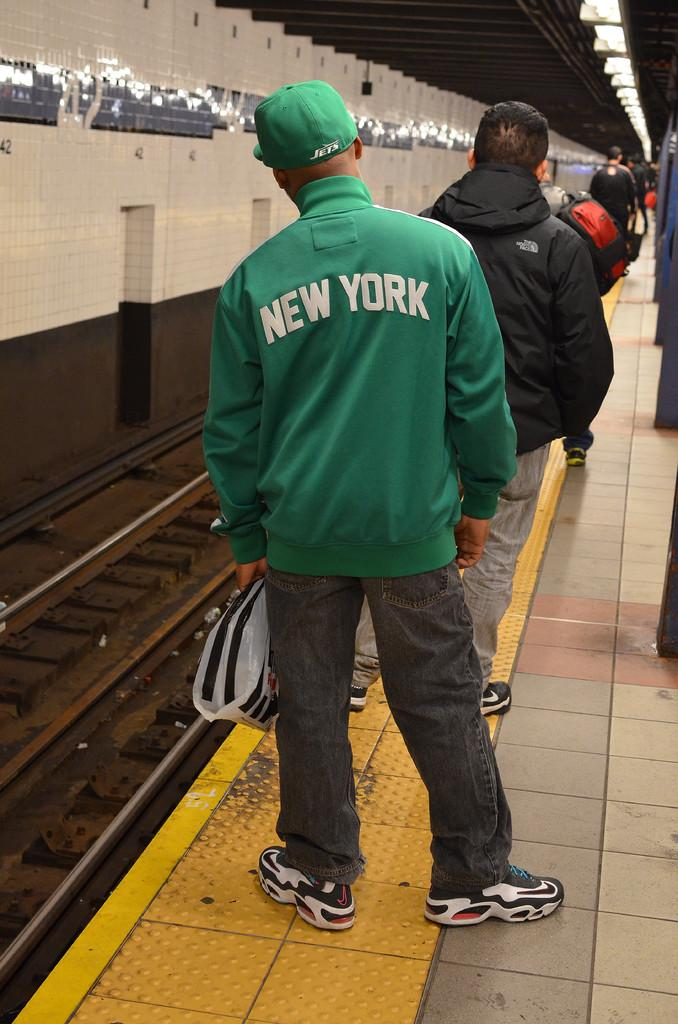What is the main subject of the image? There is a man standing in the image. Can you describe the man's clothing? The man is wearing a green cap. What can be seen on the left side of the image? There is a train track on the left side of the image. What type of cord is the man using to cover the downtown area in the image? There is no mention of a downtown area, cord, or covering in the image. 